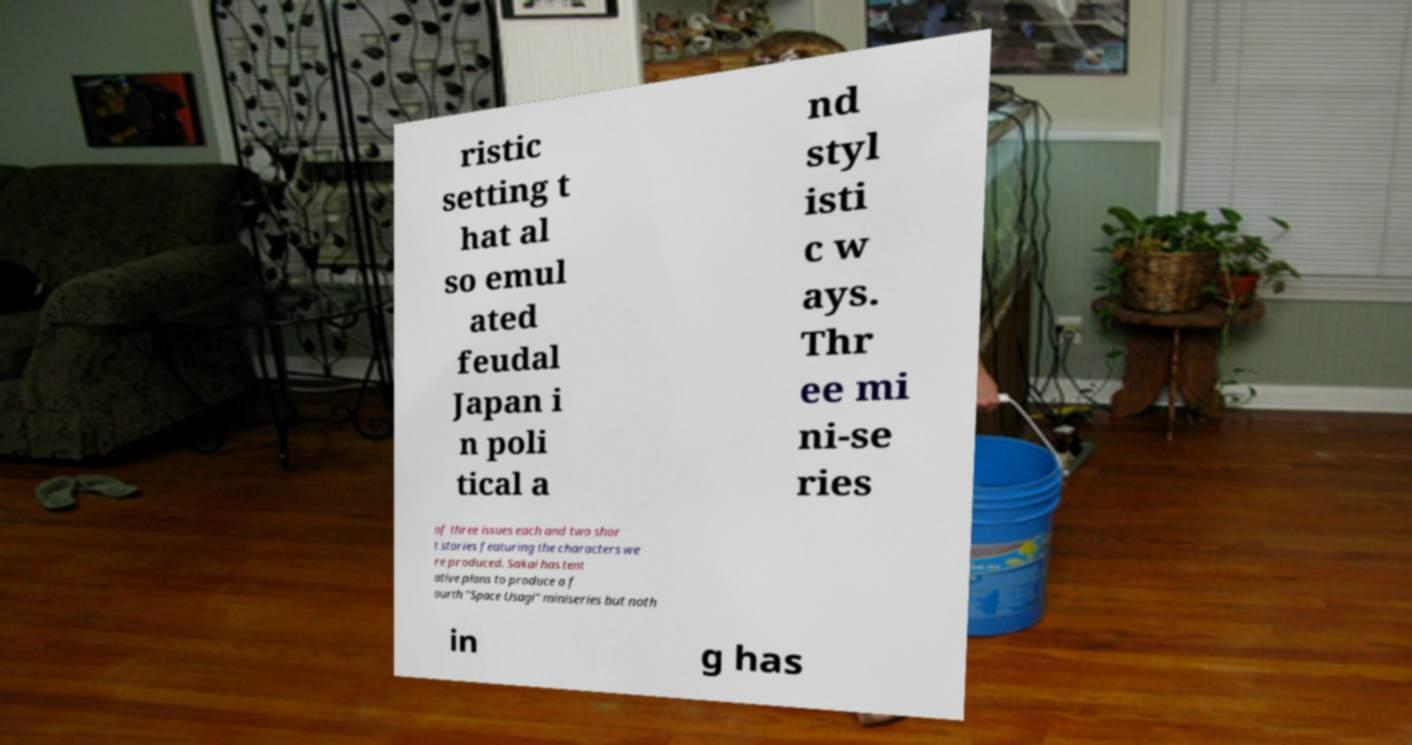Could you assist in decoding the text presented in this image and type it out clearly? ristic setting t hat al so emul ated feudal Japan i n poli tical a nd styl isti c w ays. Thr ee mi ni-se ries of three issues each and two shor t stories featuring the characters we re produced. Sakai has tent ative plans to produce a f ourth "Space Usagi" miniseries but noth in g has 